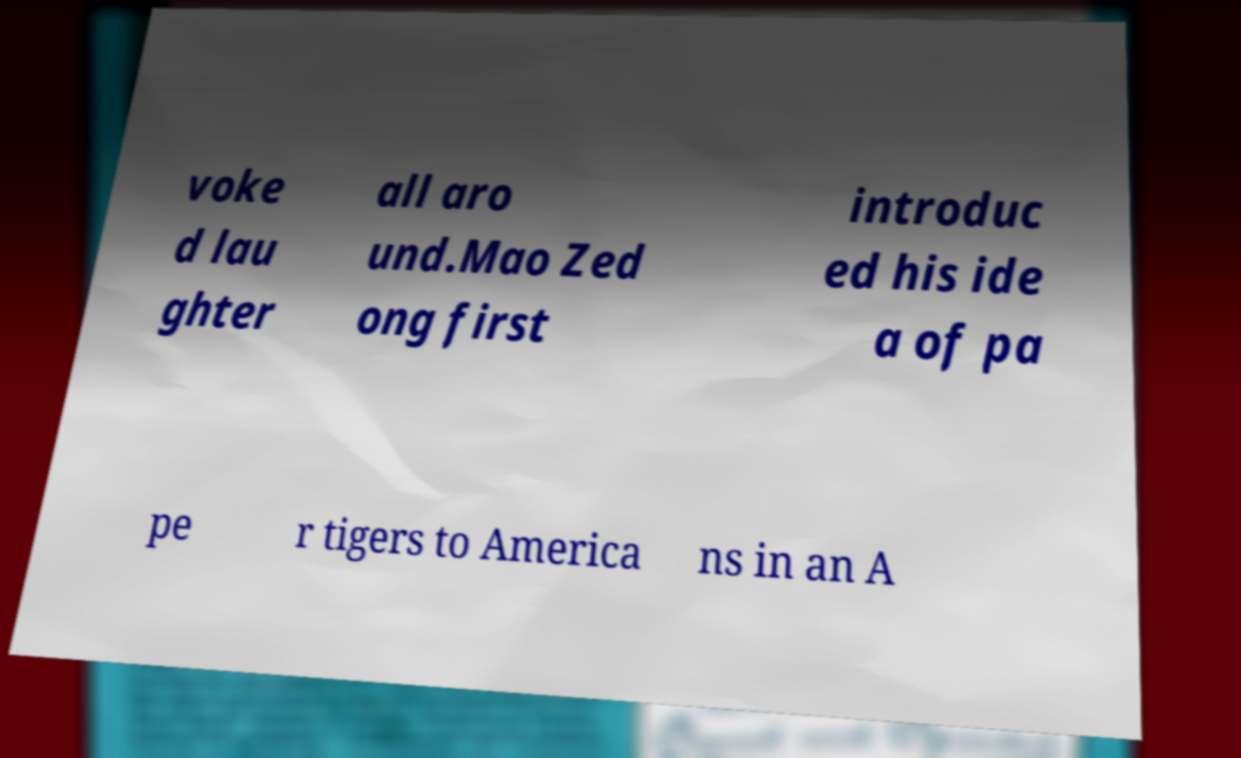Can you read and provide the text displayed in the image?This photo seems to have some interesting text. Can you extract and type it out for me? voke d lau ghter all aro und.Mao Zed ong first introduc ed his ide a of pa pe r tigers to America ns in an A 